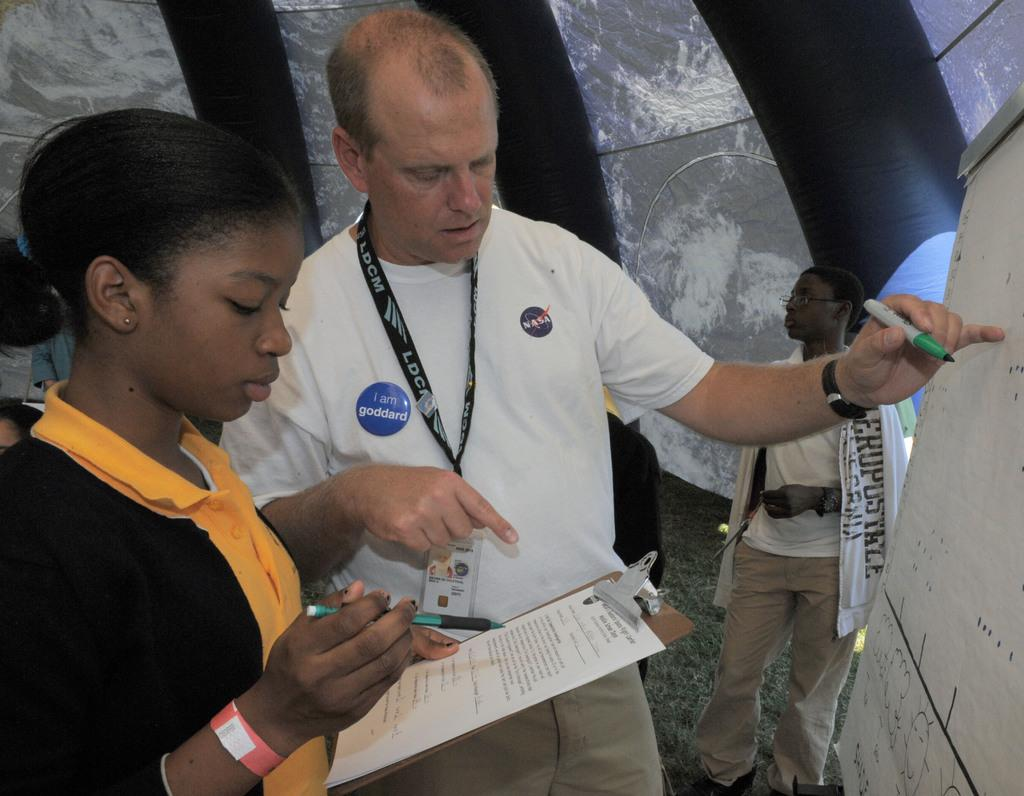How many people are in the image? There are three persons in the image. What is one person holding in the image? One person is holding an exam pad. What is the other person doing in the image? The other person is writing something on a board. What type of sign can be seen hanging from the ceiling in the image? There is no sign hanging from the ceiling in the image; the image only shows three persons, one holding an exam pad and the other writing on a board. 